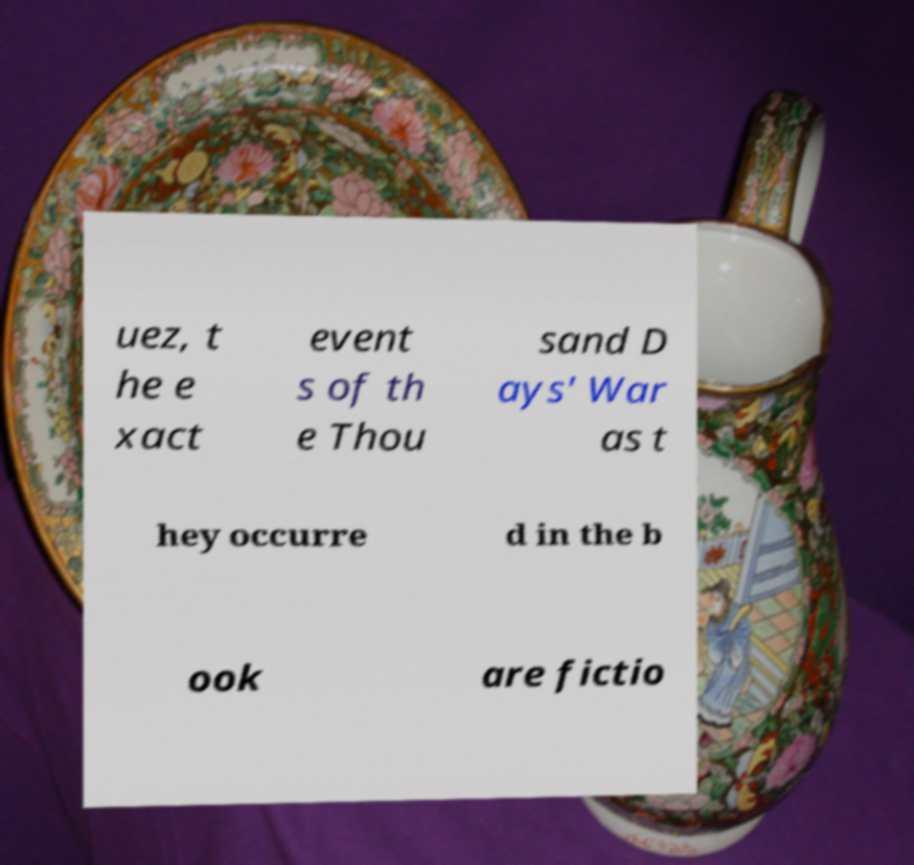What messages or text are displayed in this image? I need them in a readable, typed format. uez, t he e xact event s of th e Thou sand D ays' War as t hey occurre d in the b ook are fictio 